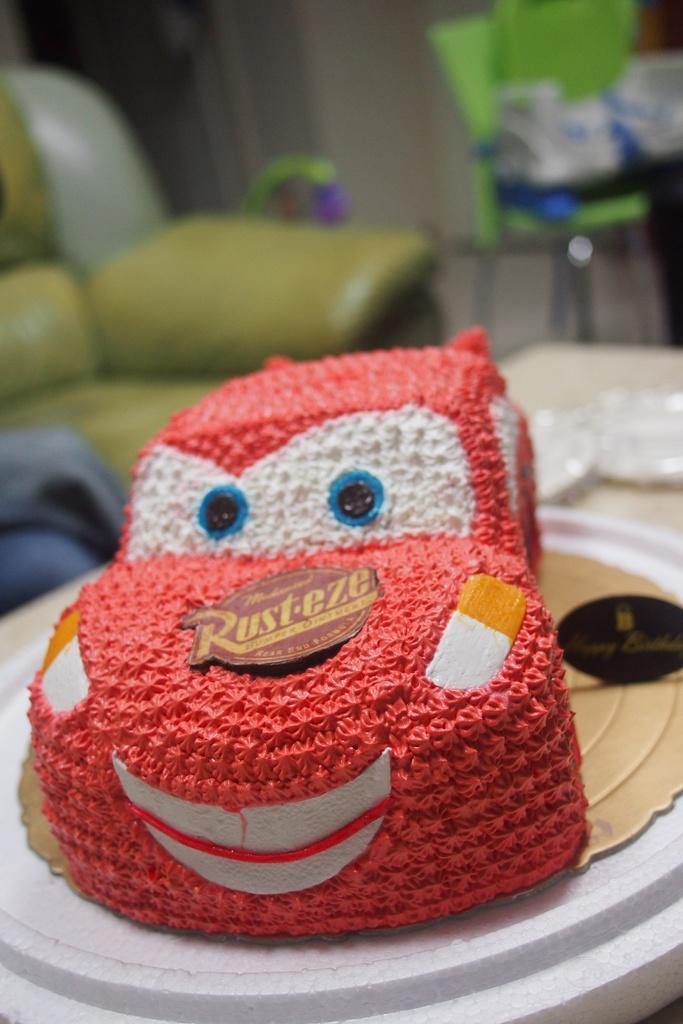What is located in the foreground of the image? There is a table in the foreground of the image. What is on the table? There is a bag on the table. What can be seen in the background of the image? There is a sofa, chairs, and a wall visible in the background of the image. Where was the image taken? The image was taken in a room. What type of bear is sitting on the sofa in the image? There is no bear present in the image; it only features a table, a bag, a sofa, chairs, and a wall. What achievements has the achiever accomplished in the image? There is no achiever or any indication of achievements in the image. 